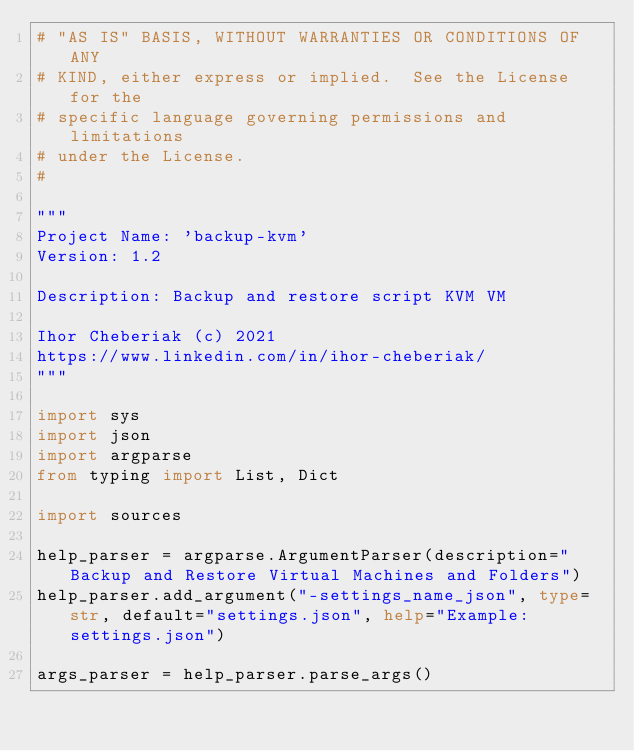<code> <loc_0><loc_0><loc_500><loc_500><_Python_># "AS IS" BASIS, WITHOUT WARRANTIES OR CONDITIONS OF ANY
# KIND, either express or implied.  See the License for the
# specific language governing permissions and limitations
# under the License.
#

"""
Project Name: 'backup-kvm'
Version: 1.2

Description: Backup and restore script KVM VM

Ihor Cheberiak (c) 2021
https://www.linkedin.com/in/ihor-cheberiak/
"""

import sys
import json
import argparse
from typing import List, Dict

import sources

help_parser = argparse.ArgumentParser(description="Backup and Restore Virtual Machines and Folders")
help_parser.add_argument("-settings_name_json", type=str, default="settings.json", help="Example: settings.json")

args_parser = help_parser.parse_args()</code> 